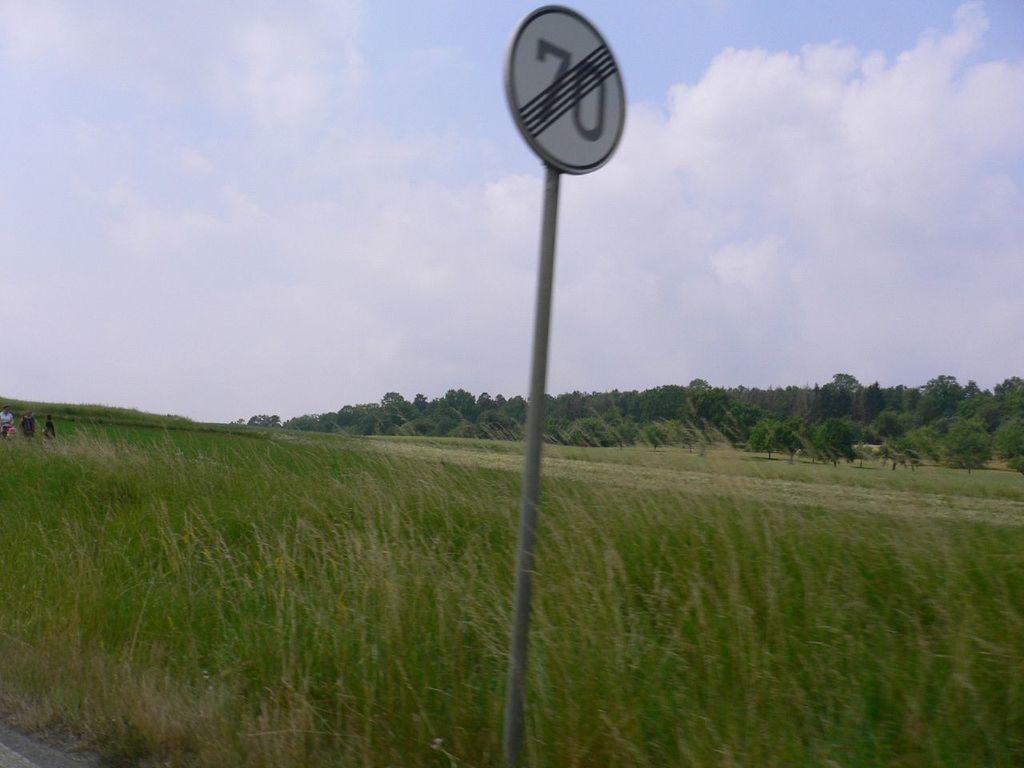Please provide a concise description of this image. In this picture I can observe a pole in the middle of the image. There is some a board fixed to this pole. I can observe some grass on the ground. In the background there are trees and a cloudy sky. 